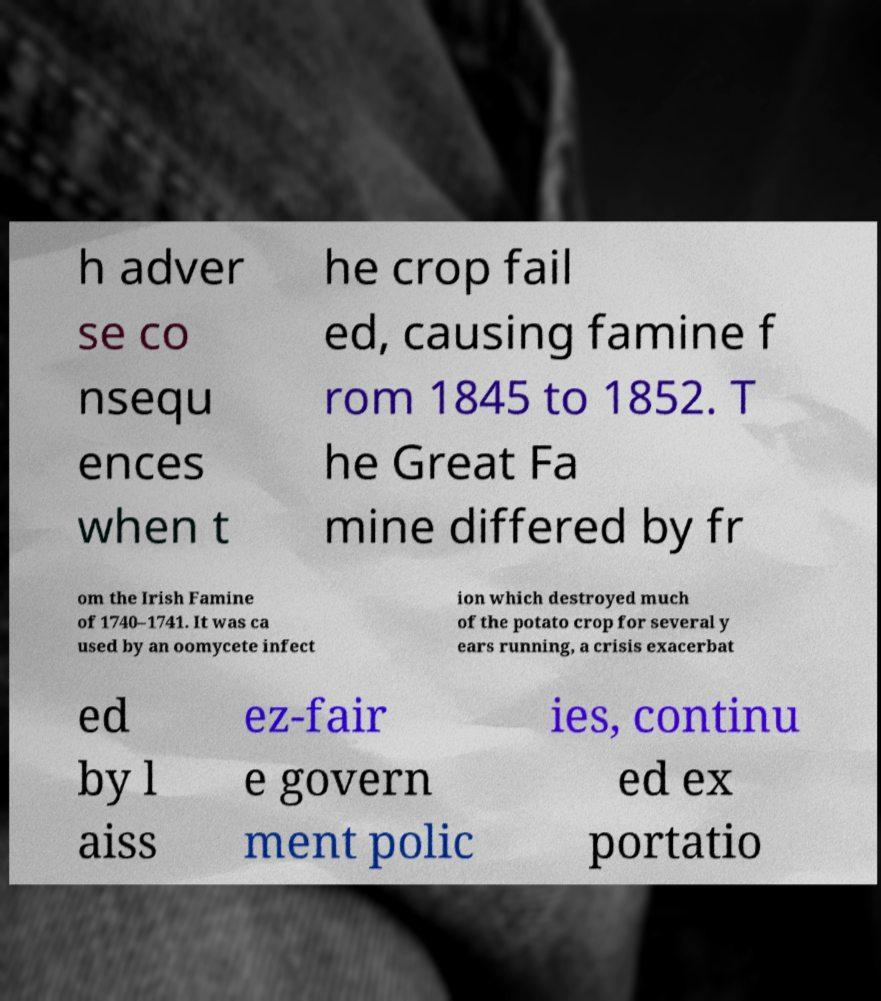Please identify and transcribe the text found in this image. h adver se co nsequ ences when t he crop fail ed, causing famine f rom 1845 to 1852. T he Great Fa mine differed by fr om the Irish Famine of 1740–1741. It was ca used by an oomycete infect ion which destroyed much of the potato crop for several y ears running, a crisis exacerbat ed by l aiss ez-fair e govern ment polic ies, continu ed ex portatio 